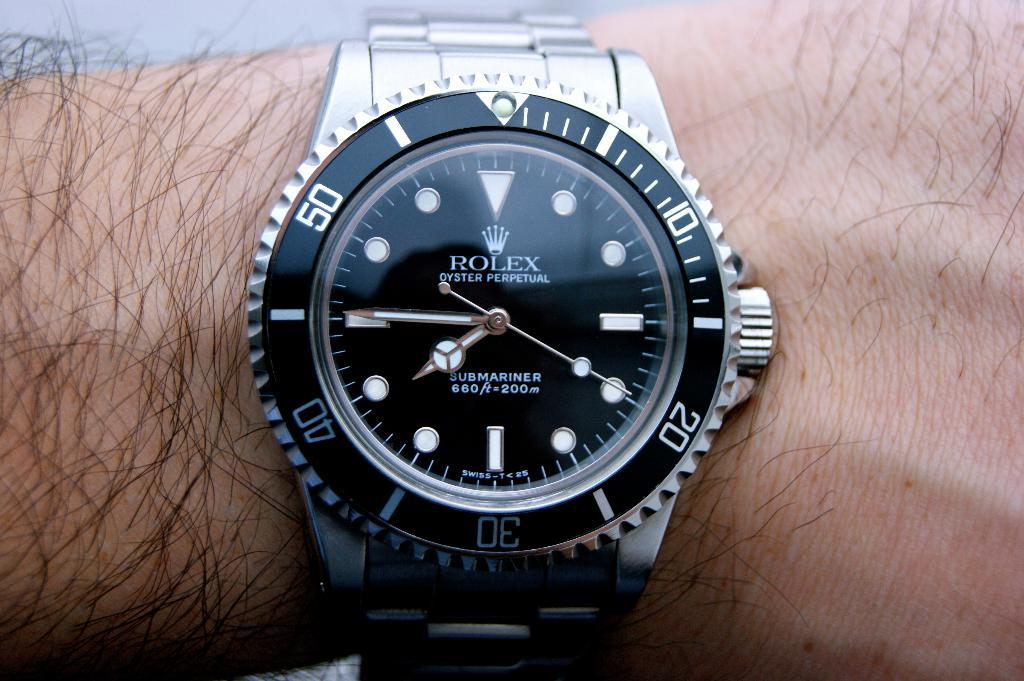<image>
Provide a brief description of the given image. A person is wearing a silver Rolex watch with a black face. 